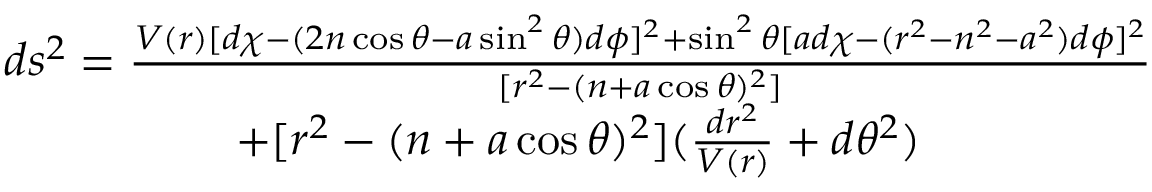<formula> <loc_0><loc_0><loc_500><loc_500>\begin{array} { c } { { d s ^ { 2 } = \frac { V ( r ) [ d \chi - ( 2 n \cos \theta - a \sin ^ { 2 } \theta ) d \phi ] ^ { 2 } + \sin ^ { 2 } \theta [ a d \chi - ( r ^ { 2 } - n ^ { 2 } - a ^ { 2 } ) d \phi ] ^ { 2 } } { [ r ^ { 2 } - ( n + a \cos \theta ) ^ { 2 } ] } } } \\ { { + [ r ^ { 2 } - ( n + a \cos \theta ) ^ { 2 } ] ( \frac { d r ^ { 2 } } { V ( r ) } + d \theta ^ { 2 } ) } } \end{array}</formula> 